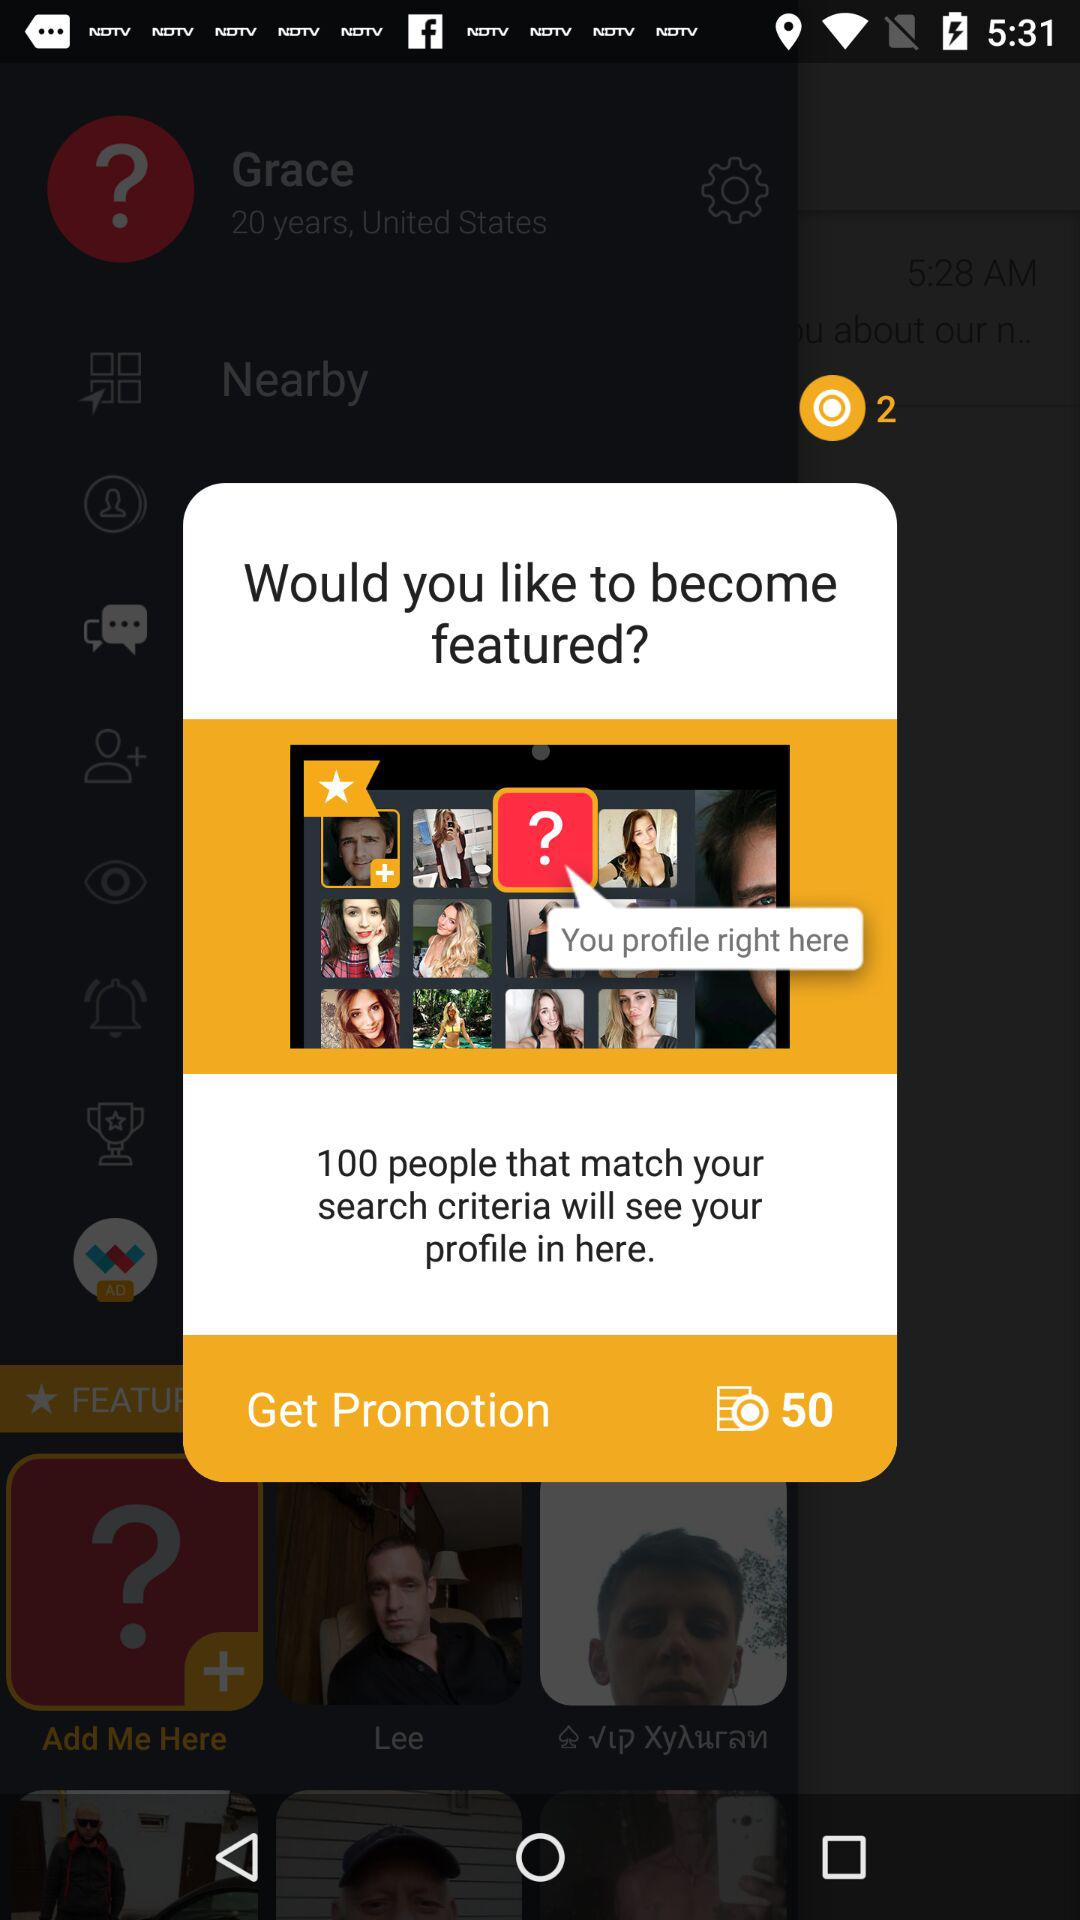How does the app determine which profiles to feature? Profiles may be featured based on various factors, including user activity, the completeness of a profile, or compatibility with search criteria. Some platforms feature profiles based on paid promotions or as part of a membership plan. 